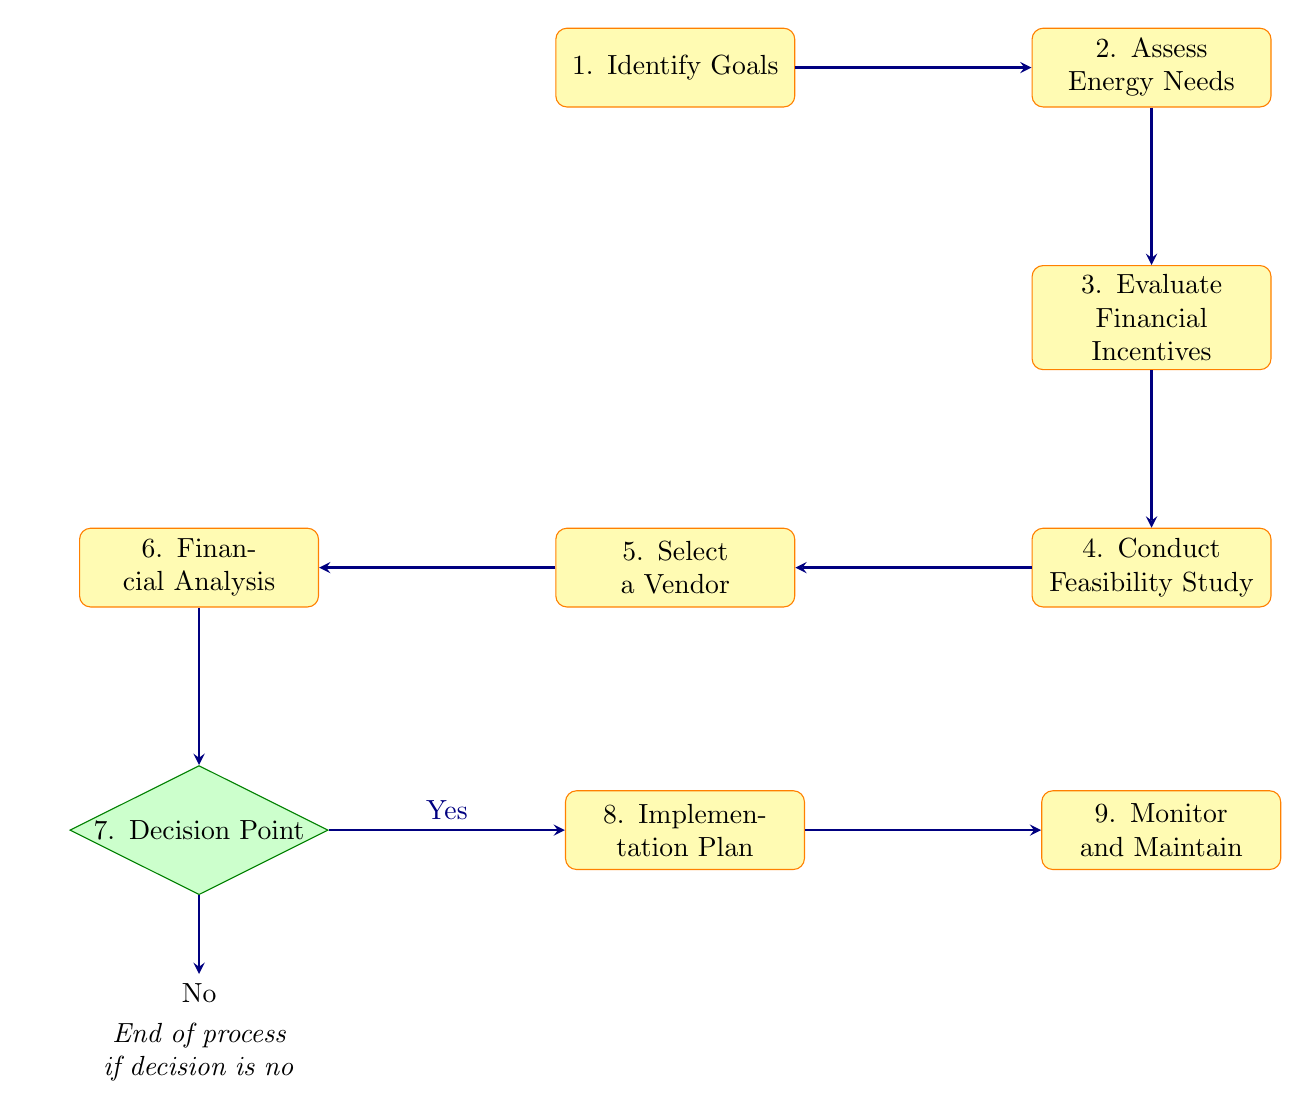What is the first step in the decision-making process? The first step is "Identify Goals." This can be found at the top of the diagram and is the starting point of the flow.
Answer: Identify Goals How many nodes are present in the diagram? By counting all unique labels in the diagram, we find that there are nine distinct nodes that represent different steps in the process.
Answer: Nine What is the final step in the process? The last node in the flowchart is "Monitor and Maintain," which indicates the final action after implementing solar energy.
Answer: Monitor and Maintain What should be evaluated after assessing energy needs? After "Assess Energy Needs," the next step in the process is "Evaluate Financial Incentives." This connection shows the sequential flow from energy assessment to financial assessment.
Answer: Evaluate Financial Incentives What is the decision point labeled in the diagram? The decision point, which evaluates whether to proceed with the investment, is labeled "Decision Point." This node is a key element in the diagram as it determines the continuation of the process.
Answer: Decision Point What happens if the decision is 'No'? If the decision is 'No,' as indicated by the arrow at the decision point, the process ends without further action. The diagram explicitly shows that there are no subsequent steps if the investment is not approved.
Answer: End of process if decision is no What is the purpose of conducting a feasibility study? The feasibility study, labeled as "Conduct Feasibility Study," serves the purpose of analyzing site suitability, solar potential, and initial costs, summary information provided in the description of the node.
Answer: Analyze site suitability, solar potential, and initial costs How does one progress from selecting a vendor to the financial analysis? The progression from "Select a Vendor" to "Financial Analysis" is indicated by an arrow that shows the required order of actions in the decision-making process.
Answer: By researching and choosing a vendor What step follows the financial analysis? Following the "Financial Analysis" step, the next action is to reach the "Decision Point," indicating that financial considerations must be evaluated before making a final investment decision.
Answer: Decision Point 